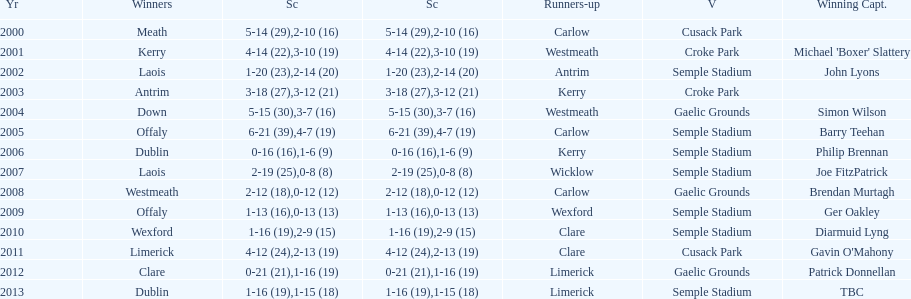How many winners won in semple stadium? 7. 